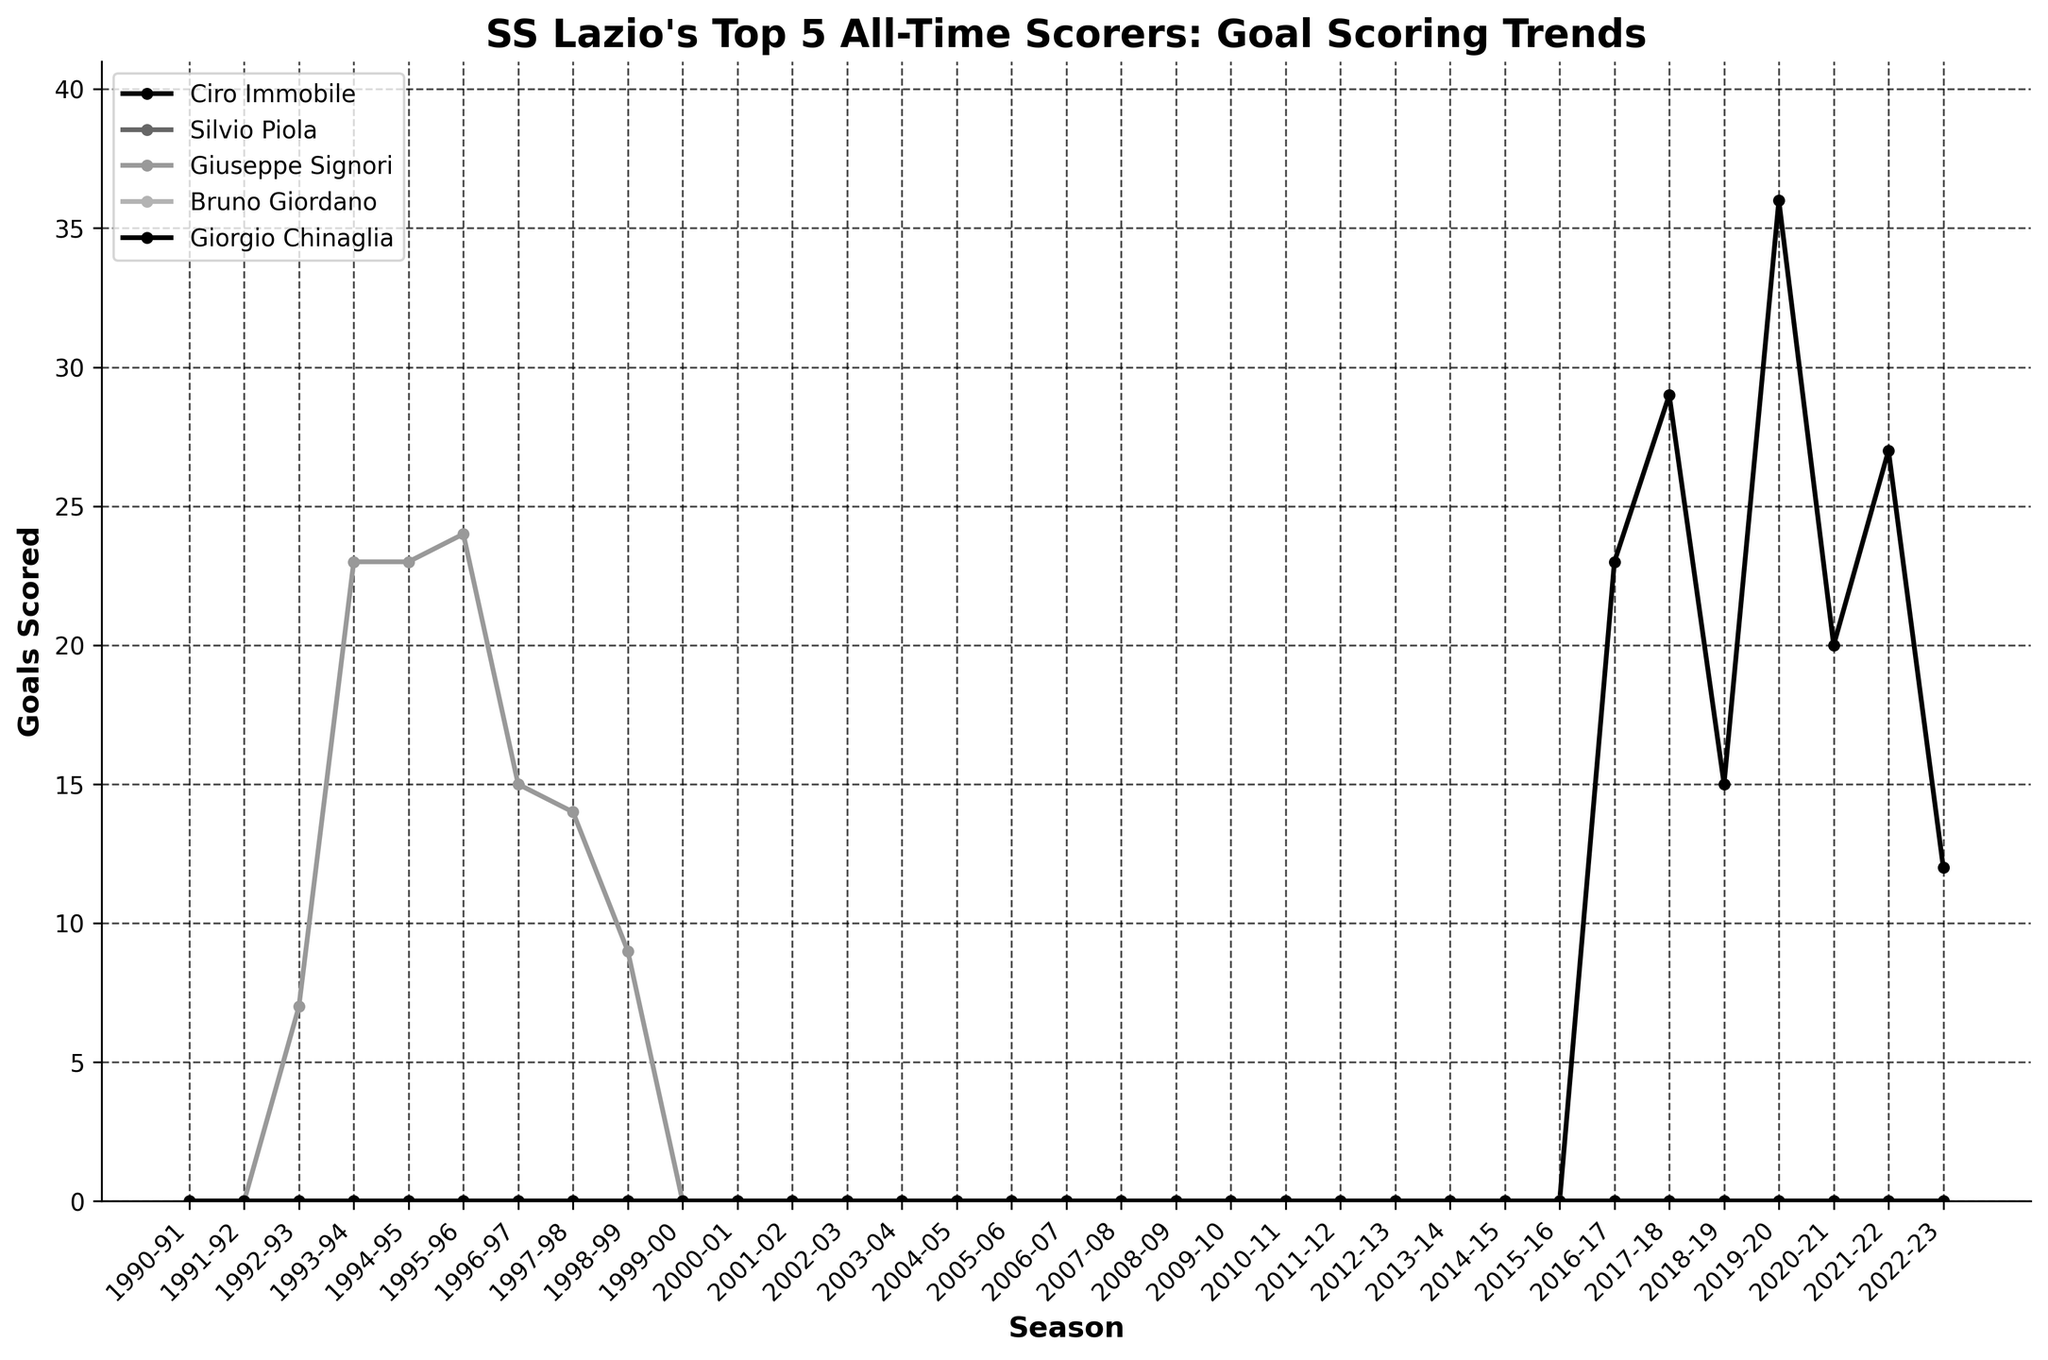How many goals did Ciro Immobile score in the 2020-21 season? From the plot, locate the line representing Ciro Immobile and find the data point corresponding to the 2020-21 season.
Answer: 20 Which player had the highest single-season goal total and in which season? Observe the peaks of the lines representing each player. The highest peak is from Ciro Immobile in the 2019-20 season.
Answer: Ciro Immobile, 2019-20 Compare the goals scored by Giuseppe Signori and Ciro Immobile in their respective peak seasons. Who scored more and by how many goals? Identify the highest points for Giuseppe Signori and Ciro Immobile. Giuseppe Signori's peak is 24 goals in 1995-96, and Ciro Immobile's peak is 36 goals in 2019-20. The difference is 36 - 24.
Answer: Ciro Immobile, 12 goals In how many seasons did Ciro Immobile score more than 25 goals? From the plot, count the number of data points above 25 on Ciro Immobile's line. These are in the 2017-18, 2019-20, and 2021-22 seasons.
Answer: 3 seasons What is the average number of goals scored by Ciro Immobile over his highest three scoring seasons? Identify the three highest data points for Ciro Immobile (36, 29, 27). Calculate the average: (36 + 29 + 27) / 3.
Answer: 30.67 Who among the top 5 scorers had consistent goal-scoring seasons with no extreme peaks or valleys? Look for a relatively flat and low line without sharp peaks or dips. Giuseppe Signori’s goal-scoring trend appears most consistent within a moderate range.
Answer: Giuseppe Signori In which season did Giuseppe Signori start his goal-scoring trend, and how many goals did he score that first season? Find the starting point of Giuseppe Signori's line. It begins in the 1992-93 season with 7 goals.
Answer: 1992-93, 7 goals Did any player from the top 5 all-time scorers of SS Lazio score goals in both the 20th and 21st centuries? Check each player's timeline to see if any player's goal-scoring spans both centuries. Only Ciro Immobile's career falls entirely within the 21st century.
Answer: None Compare the overall scoring trends between Ciro Immobile and Giuseppe Signori. Whose trend is more variable and why? Analyze the lines for both players. Ciro Immobile's line shows more fluctuations with significant peaks and dips, while Giuseppe Signori's line is relatively steady. Thus, Ciro Immobile's trend is more variable.
Answer: Ciro Immobile In how many seasons did Ciro Immobile score exactly 0 goals within the given data? Check Ciro Immobile's line and count the data points at 0. As Ciro Immobile appears only from 2016-17 onwards and scored goals in each season, the count is 0.
Answer: 0 seasons 